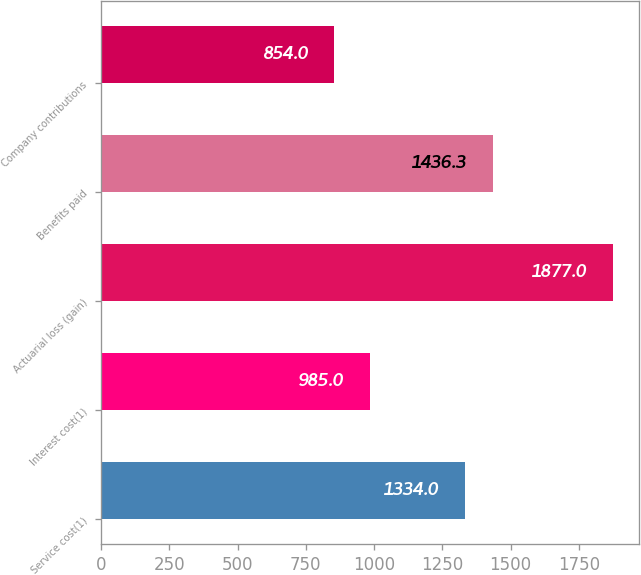Convert chart. <chart><loc_0><loc_0><loc_500><loc_500><bar_chart><fcel>Service cost(1)<fcel>Interest cost(1)<fcel>Actuarial loss (gain)<fcel>Benefits paid<fcel>Company contributions<nl><fcel>1334<fcel>985<fcel>1877<fcel>1436.3<fcel>854<nl></chart> 